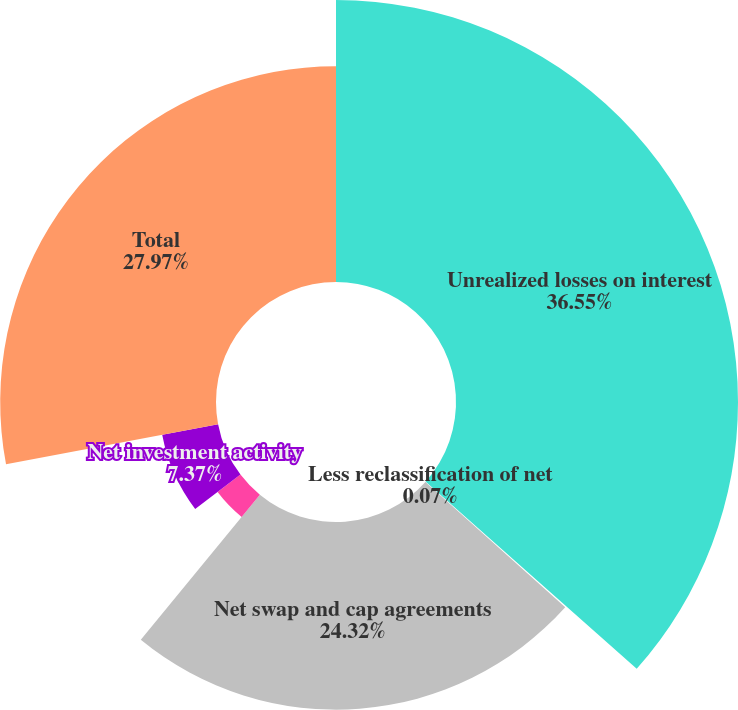Convert chart. <chart><loc_0><loc_0><loc_500><loc_500><pie_chart><fcel>Unrealized losses on interest<fcel>Less reclassification of net<fcel>Net swap and cap agreements<fcel>Unrealized losses on<fcel>Net investment activity<fcel>Total<nl><fcel>36.55%<fcel>0.07%<fcel>24.32%<fcel>3.72%<fcel>7.37%<fcel>27.97%<nl></chart> 